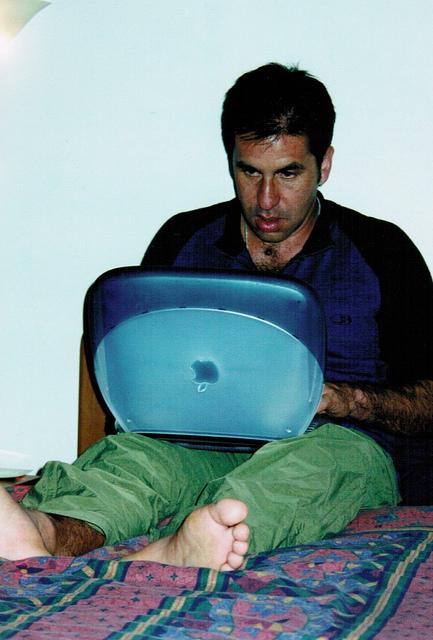What font is used in Apple logo? san francisco 